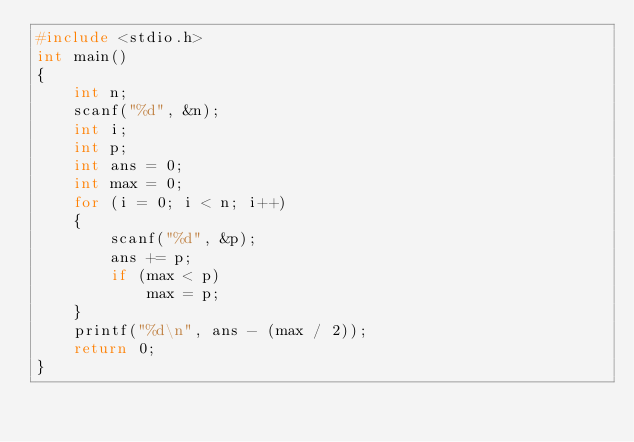<code> <loc_0><loc_0><loc_500><loc_500><_C_>#include <stdio.h>
int main()
{
    int n;
    scanf("%d", &n);
    int i;
    int p;
    int ans = 0;
    int max = 0;
    for (i = 0; i < n; i++)
    {
        scanf("%d", &p);
        ans += p;
        if (max < p)
            max = p;
    }
    printf("%d\n", ans - (max / 2));
    return 0;
}</code> 